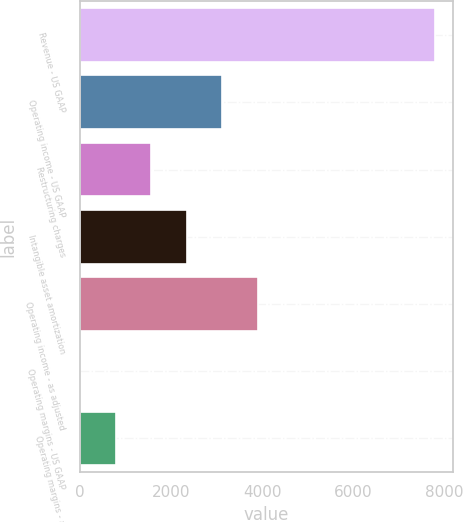Convert chart. <chart><loc_0><loc_0><loc_500><loc_500><bar_chart><fcel>Revenue - US GAAP<fcel>Operating income - US GAAP<fcel>Restructuring charges<fcel>Intangible asset amortization<fcel>Operating income - as adjusted<fcel>Operating margins - US GAAP<fcel>Operating margins - as<nl><fcel>7789<fcel>3127.48<fcel>1573.64<fcel>2350.56<fcel>3904.4<fcel>19.8<fcel>796.72<nl></chart> 